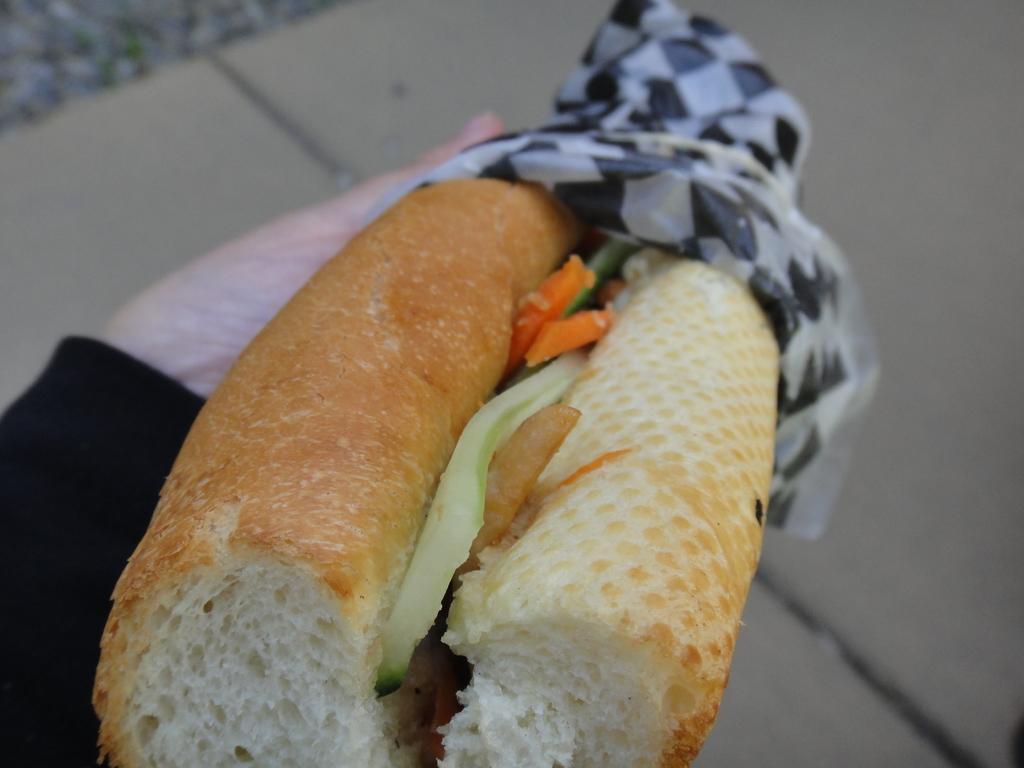Could you give a brief overview of what you see in this image? In this picture we can see food in the hand. 